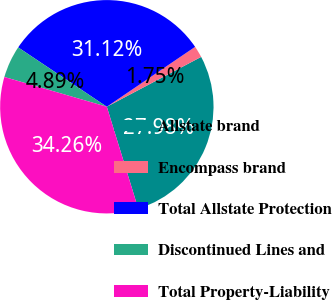Convert chart. <chart><loc_0><loc_0><loc_500><loc_500><pie_chart><fcel>Allstate brand<fcel>Encompass brand<fcel>Total Allstate Protection<fcel>Discontinued Lines and<fcel>Total Property-Liability<nl><fcel>27.98%<fcel>1.75%<fcel>31.12%<fcel>4.89%<fcel>34.26%<nl></chart> 